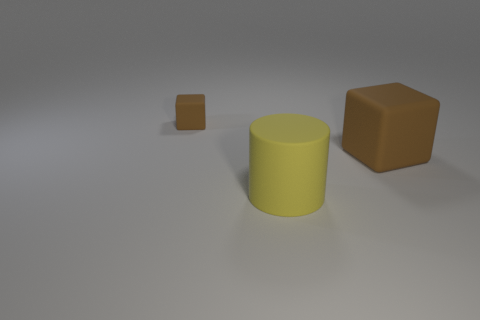There is a matte thing that is in front of the big brown cube; does it have the same shape as the rubber object that is right of the yellow cylinder?
Give a very brief answer. No. Are there any brown matte objects in front of the yellow rubber cylinder?
Ensure brevity in your answer.  No. There is another thing that is the same shape as the large brown rubber object; what color is it?
Provide a short and direct response. Brown. Is there any other thing that is the same shape as the big yellow thing?
Provide a short and direct response. No. There is another brown thing that is the same shape as the tiny brown rubber object; what size is it?
Your answer should be compact. Large. How many tiny objects have the same material as the big brown thing?
Keep it short and to the point. 1. What number of other things are the same color as the small rubber object?
Provide a succinct answer. 1. How many objects are matte objects that are behind the cylinder or rubber things behind the yellow rubber cylinder?
Ensure brevity in your answer.  2. Is the number of big yellow cylinders in front of the cylinder less than the number of cylinders?
Give a very brief answer. Yes. Are there any purple metal objects that have the same size as the yellow cylinder?
Ensure brevity in your answer.  No. 